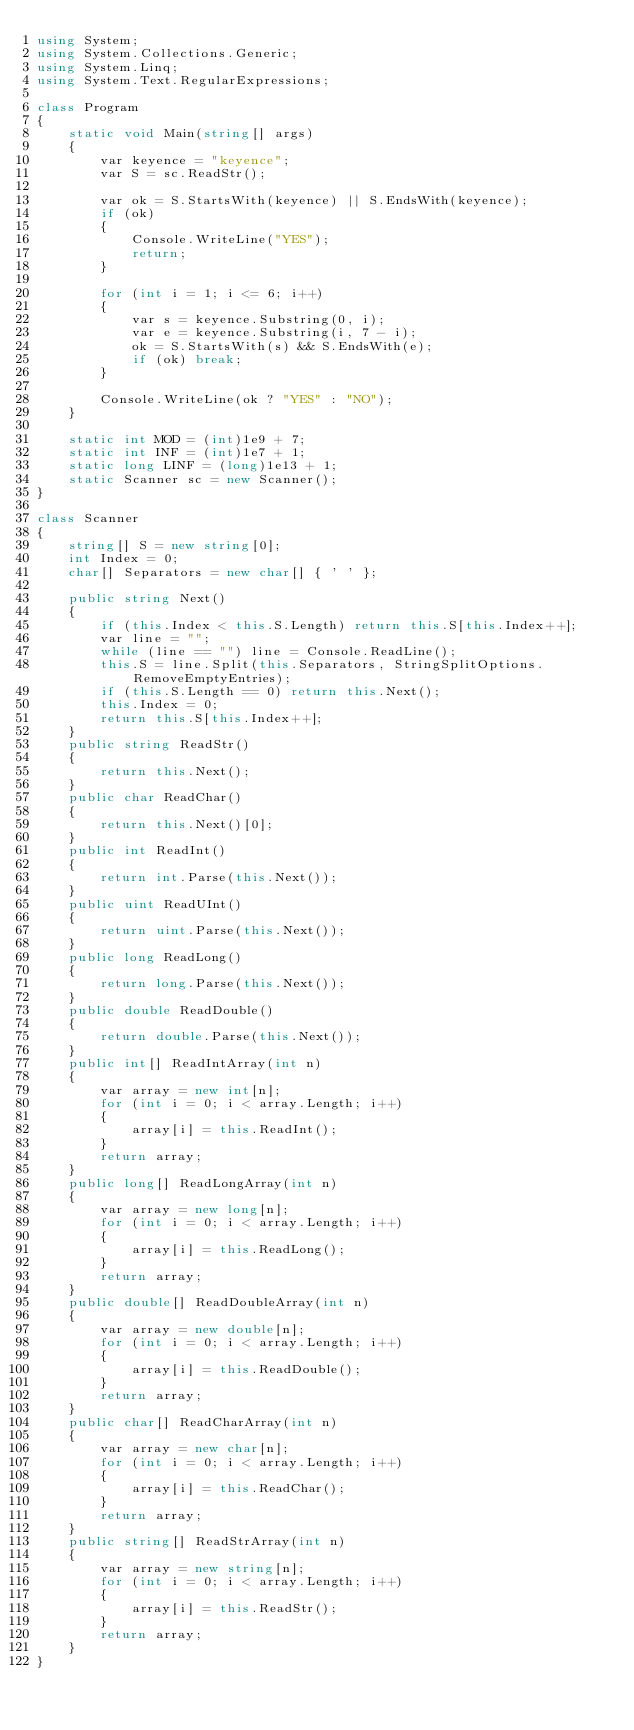<code> <loc_0><loc_0><loc_500><loc_500><_C#_>using System;
using System.Collections.Generic;
using System.Linq;
using System.Text.RegularExpressions;

class Program
{
    static void Main(string[] args)
    {
        var keyence = "keyence";
        var S = sc.ReadStr();

        var ok = S.StartsWith(keyence) || S.EndsWith(keyence);
        if (ok)
        {
            Console.WriteLine("YES");
            return;
        }

        for (int i = 1; i <= 6; i++)
        {
            var s = keyence.Substring(0, i);
            var e = keyence.Substring(i, 7 - i);
            ok = S.StartsWith(s) && S.EndsWith(e);
            if (ok) break;
        }

        Console.WriteLine(ok ? "YES" : "NO");
    }

    static int MOD = (int)1e9 + 7;
    static int INF = (int)1e7 + 1;
    static long LINF = (long)1e13 + 1;
    static Scanner sc = new Scanner();
}

class Scanner
{
    string[] S = new string[0];
    int Index = 0;
    char[] Separators = new char[] { ' ' };

    public string Next()
    {
        if (this.Index < this.S.Length) return this.S[this.Index++];
        var line = "";
        while (line == "") line = Console.ReadLine();
        this.S = line.Split(this.Separators, StringSplitOptions.RemoveEmptyEntries);
        if (this.S.Length == 0) return this.Next();
        this.Index = 0;
        return this.S[this.Index++];
    }
    public string ReadStr()
    {
        return this.Next();
    }
    public char ReadChar()
    {
        return this.Next()[0];
    }
    public int ReadInt()
    {
        return int.Parse(this.Next());
    }
    public uint ReadUInt()
    {
        return uint.Parse(this.Next());
    }
    public long ReadLong()
    {
        return long.Parse(this.Next());
    }
    public double ReadDouble()
    {
        return double.Parse(this.Next());
    }
    public int[] ReadIntArray(int n)
    {
        var array = new int[n];
        for (int i = 0; i < array.Length; i++)
        {
            array[i] = this.ReadInt();
        }
        return array;
    }
    public long[] ReadLongArray(int n)
    {
        var array = new long[n];
        for (int i = 0; i < array.Length; i++)
        {
            array[i] = this.ReadLong();
        }
        return array;
    }
    public double[] ReadDoubleArray(int n)
    {
        var array = new double[n];
        for (int i = 0; i < array.Length; i++)
        {
            array[i] = this.ReadDouble();
        }
        return array;
    }
    public char[] ReadCharArray(int n)
    {
        var array = new char[n];
        for (int i = 0; i < array.Length; i++)
        {
            array[i] = this.ReadChar();
        }
        return array;
    }
    public string[] ReadStrArray(int n)
    {
        var array = new string[n];
        for (int i = 0; i < array.Length; i++)
        {
            array[i] = this.ReadStr();
        }
        return array;
    }
}

</code> 